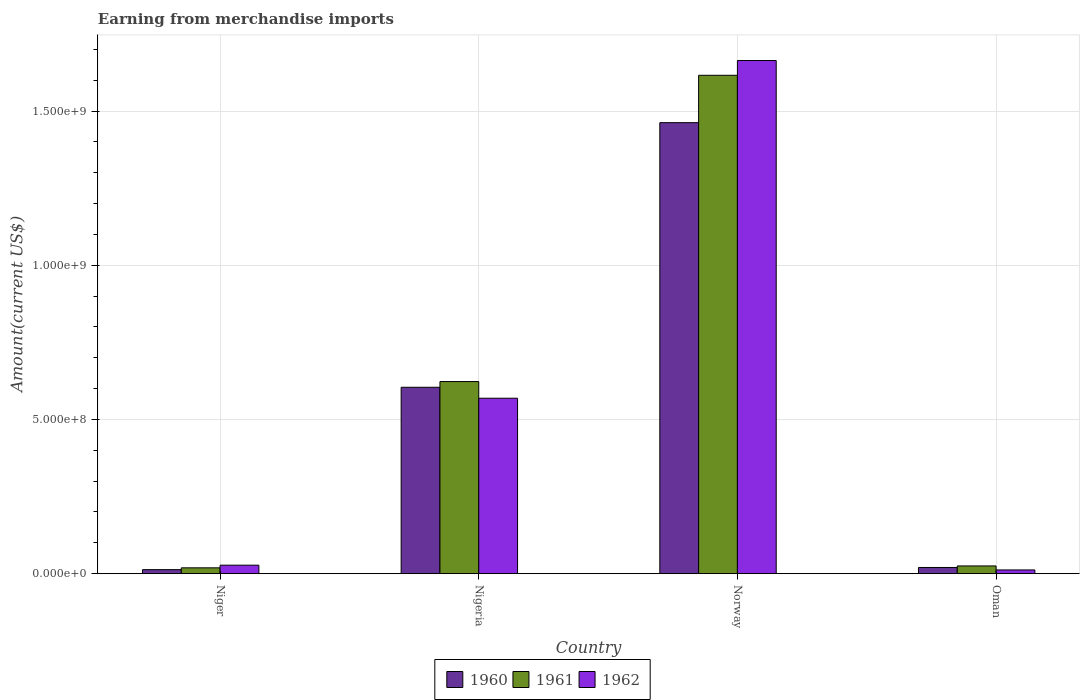Are the number of bars per tick equal to the number of legend labels?
Offer a very short reply. Yes. Are the number of bars on each tick of the X-axis equal?
Make the answer very short. Yes. How many bars are there on the 2nd tick from the left?
Give a very brief answer. 3. How many bars are there on the 1st tick from the right?
Ensure brevity in your answer.  3. What is the amount earned from merchandise imports in 1960 in Niger?
Keep it short and to the point. 1.30e+07. Across all countries, what is the maximum amount earned from merchandise imports in 1961?
Ensure brevity in your answer.  1.62e+09. Across all countries, what is the minimum amount earned from merchandise imports in 1962?
Offer a very short reply. 1.20e+07. In which country was the amount earned from merchandise imports in 1962 maximum?
Your response must be concise. Norway. In which country was the amount earned from merchandise imports in 1960 minimum?
Your answer should be compact. Niger. What is the total amount earned from merchandise imports in 1962 in the graph?
Ensure brevity in your answer.  2.27e+09. What is the difference between the amount earned from merchandise imports in 1961 in Niger and that in Oman?
Offer a very short reply. -6.15e+06. What is the difference between the amount earned from merchandise imports in 1960 in Oman and the amount earned from merchandise imports in 1961 in Nigeria?
Your response must be concise. -6.03e+08. What is the average amount earned from merchandise imports in 1961 per country?
Your answer should be compact. 5.71e+08. What is the difference between the amount earned from merchandise imports of/in 1962 and amount earned from merchandise imports of/in 1960 in Oman?
Your response must be concise. -8.00e+06. In how many countries, is the amount earned from merchandise imports in 1962 greater than 800000000 US$?
Make the answer very short. 1. What is the ratio of the amount earned from merchandise imports in 1961 in Niger to that in Oman?
Your answer should be compact. 0.75. Is the amount earned from merchandise imports in 1962 in Norway less than that in Oman?
Your response must be concise. No. Is the difference between the amount earned from merchandise imports in 1962 in Niger and Norway greater than the difference between the amount earned from merchandise imports in 1960 in Niger and Norway?
Keep it short and to the point. No. What is the difference between the highest and the second highest amount earned from merchandise imports in 1961?
Give a very brief answer. 1.59e+09. What is the difference between the highest and the lowest amount earned from merchandise imports in 1962?
Give a very brief answer. 1.65e+09. In how many countries, is the amount earned from merchandise imports in 1962 greater than the average amount earned from merchandise imports in 1962 taken over all countries?
Your response must be concise. 2. What does the 3rd bar from the left in Nigeria represents?
Your response must be concise. 1962. Is it the case that in every country, the sum of the amount earned from merchandise imports in 1962 and amount earned from merchandise imports in 1961 is greater than the amount earned from merchandise imports in 1960?
Provide a short and direct response. Yes. How many bars are there?
Provide a short and direct response. 12. How many countries are there in the graph?
Provide a short and direct response. 4. Does the graph contain any zero values?
Your answer should be compact. No. Where does the legend appear in the graph?
Give a very brief answer. Bottom center. How are the legend labels stacked?
Provide a short and direct response. Horizontal. What is the title of the graph?
Your response must be concise. Earning from merchandise imports. What is the label or title of the Y-axis?
Your answer should be compact. Amount(current US$). What is the Amount(current US$) of 1960 in Niger?
Your answer should be compact. 1.30e+07. What is the Amount(current US$) in 1961 in Niger?
Give a very brief answer. 1.88e+07. What is the Amount(current US$) of 1962 in Niger?
Offer a terse response. 2.75e+07. What is the Amount(current US$) in 1960 in Nigeria?
Your response must be concise. 6.04e+08. What is the Amount(current US$) of 1961 in Nigeria?
Provide a succinct answer. 6.23e+08. What is the Amount(current US$) in 1962 in Nigeria?
Your answer should be compact. 5.69e+08. What is the Amount(current US$) of 1960 in Norway?
Provide a succinct answer. 1.46e+09. What is the Amount(current US$) of 1961 in Norway?
Provide a succinct answer. 1.62e+09. What is the Amount(current US$) in 1962 in Norway?
Make the answer very short. 1.66e+09. What is the Amount(current US$) in 1961 in Oman?
Your response must be concise. 2.50e+07. Across all countries, what is the maximum Amount(current US$) in 1960?
Offer a very short reply. 1.46e+09. Across all countries, what is the maximum Amount(current US$) of 1961?
Give a very brief answer. 1.62e+09. Across all countries, what is the maximum Amount(current US$) of 1962?
Your answer should be compact. 1.66e+09. Across all countries, what is the minimum Amount(current US$) of 1960?
Ensure brevity in your answer.  1.30e+07. Across all countries, what is the minimum Amount(current US$) of 1961?
Offer a terse response. 1.88e+07. Across all countries, what is the minimum Amount(current US$) in 1962?
Keep it short and to the point. 1.20e+07. What is the total Amount(current US$) of 1960 in the graph?
Give a very brief answer. 2.10e+09. What is the total Amount(current US$) in 1961 in the graph?
Make the answer very short. 2.28e+09. What is the total Amount(current US$) in 1962 in the graph?
Your answer should be compact. 2.27e+09. What is the difference between the Amount(current US$) of 1960 in Niger and that in Nigeria?
Your answer should be compact. -5.91e+08. What is the difference between the Amount(current US$) of 1961 in Niger and that in Nigeria?
Keep it short and to the point. -6.04e+08. What is the difference between the Amount(current US$) of 1962 in Niger and that in Nigeria?
Your answer should be very brief. -5.41e+08. What is the difference between the Amount(current US$) of 1960 in Niger and that in Norway?
Offer a very short reply. -1.45e+09. What is the difference between the Amount(current US$) of 1961 in Niger and that in Norway?
Your answer should be very brief. -1.60e+09. What is the difference between the Amount(current US$) of 1962 in Niger and that in Norway?
Provide a short and direct response. -1.64e+09. What is the difference between the Amount(current US$) of 1960 in Niger and that in Oman?
Provide a short and direct response. -7.01e+06. What is the difference between the Amount(current US$) of 1961 in Niger and that in Oman?
Provide a succinct answer. -6.15e+06. What is the difference between the Amount(current US$) of 1962 in Niger and that in Oman?
Your response must be concise. 1.55e+07. What is the difference between the Amount(current US$) of 1960 in Nigeria and that in Norway?
Make the answer very short. -8.58e+08. What is the difference between the Amount(current US$) of 1961 in Nigeria and that in Norway?
Your answer should be compact. -9.93e+08. What is the difference between the Amount(current US$) in 1962 in Nigeria and that in Norway?
Your response must be concise. -1.10e+09. What is the difference between the Amount(current US$) in 1960 in Nigeria and that in Oman?
Ensure brevity in your answer.  5.84e+08. What is the difference between the Amount(current US$) in 1961 in Nigeria and that in Oman?
Your answer should be very brief. 5.98e+08. What is the difference between the Amount(current US$) in 1962 in Nigeria and that in Oman?
Give a very brief answer. 5.57e+08. What is the difference between the Amount(current US$) in 1960 in Norway and that in Oman?
Your answer should be very brief. 1.44e+09. What is the difference between the Amount(current US$) of 1961 in Norway and that in Oman?
Give a very brief answer. 1.59e+09. What is the difference between the Amount(current US$) of 1962 in Norway and that in Oman?
Your answer should be compact. 1.65e+09. What is the difference between the Amount(current US$) of 1960 in Niger and the Amount(current US$) of 1961 in Nigeria?
Provide a short and direct response. -6.10e+08. What is the difference between the Amount(current US$) of 1960 in Niger and the Amount(current US$) of 1962 in Nigeria?
Provide a short and direct response. -5.56e+08. What is the difference between the Amount(current US$) of 1961 in Niger and the Amount(current US$) of 1962 in Nigeria?
Offer a terse response. -5.50e+08. What is the difference between the Amount(current US$) of 1960 in Niger and the Amount(current US$) of 1961 in Norway?
Offer a very short reply. -1.60e+09. What is the difference between the Amount(current US$) of 1960 in Niger and the Amount(current US$) of 1962 in Norway?
Your answer should be very brief. -1.65e+09. What is the difference between the Amount(current US$) of 1961 in Niger and the Amount(current US$) of 1962 in Norway?
Provide a short and direct response. -1.65e+09. What is the difference between the Amount(current US$) of 1960 in Niger and the Amount(current US$) of 1961 in Oman?
Provide a short and direct response. -1.20e+07. What is the difference between the Amount(current US$) in 1960 in Niger and the Amount(current US$) in 1962 in Oman?
Offer a very short reply. 9.92e+05. What is the difference between the Amount(current US$) in 1961 in Niger and the Amount(current US$) in 1962 in Oman?
Provide a short and direct response. 6.85e+06. What is the difference between the Amount(current US$) of 1960 in Nigeria and the Amount(current US$) of 1961 in Norway?
Your response must be concise. -1.01e+09. What is the difference between the Amount(current US$) of 1960 in Nigeria and the Amount(current US$) of 1962 in Norway?
Your answer should be very brief. -1.06e+09. What is the difference between the Amount(current US$) in 1961 in Nigeria and the Amount(current US$) in 1962 in Norway?
Provide a short and direct response. -1.04e+09. What is the difference between the Amount(current US$) of 1960 in Nigeria and the Amount(current US$) of 1961 in Oman?
Give a very brief answer. 5.79e+08. What is the difference between the Amount(current US$) of 1960 in Nigeria and the Amount(current US$) of 1962 in Oman?
Give a very brief answer. 5.92e+08. What is the difference between the Amount(current US$) in 1961 in Nigeria and the Amount(current US$) in 1962 in Oman?
Your answer should be compact. 6.11e+08. What is the difference between the Amount(current US$) of 1960 in Norway and the Amount(current US$) of 1961 in Oman?
Ensure brevity in your answer.  1.44e+09. What is the difference between the Amount(current US$) in 1960 in Norway and the Amount(current US$) in 1962 in Oman?
Ensure brevity in your answer.  1.45e+09. What is the difference between the Amount(current US$) in 1961 in Norway and the Amount(current US$) in 1962 in Oman?
Your answer should be very brief. 1.60e+09. What is the average Amount(current US$) in 1960 per country?
Keep it short and to the point. 5.25e+08. What is the average Amount(current US$) in 1961 per country?
Make the answer very short. 5.71e+08. What is the average Amount(current US$) of 1962 per country?
Your answer should be compact. 5.68e+08. What is the difference between the Amount(current US$) of 1960 and Amount(current US$) of 1961 in Niger?
Make the answer very short. -5.86e+06. What is the difference between the Amount(current US$) in 1960 and Amount(current US$) in 1962 in Niger?
Your answer should be compact. -1.45e+07. What is the difference between the Amount(current US$) of 1961 and Amount(current US$) of 1962 in Niger?
Offer a very short reply. -8.61e+06. What is the difference between the Amount(current US$) of 1960 and Amount(current US$) of 1961 in Nigeria?
Make the answer very short. -1.85e+07. What is the difference between the Amount(current US$) of 1960 and Amount(current US$) of 1962 in Nigeria?
Your answer should be compact. 3.56e+07. What is the difference between the Amount(current US$) of 1961 and Amount(current US$) of 1962 in Nigeria?
Provide a short and direct response. 5.40e+07. What is the difference between the Amount(current US$) in 1960 and Amount(current US$) in 1961 in Norway?
Keep it short and to the point. -1.54e+08. What is the difference between the Amount(current US$) of 1960 and Amount(current US$) of 1962 in Norway?
Your answer should be compact. -2.01e+08. What is the difference between the Amount(current US$) in 1961 and Amount(current US$) in 1962 in Norway?
Give a very brief answer. -4.79e+07. What is the difference between the Amount(current US$) in 1960 and Amount(current US$) in 1961 in Oman?
Your answer should be very brief. -5.00e+06. What is the difference between the Amount(current US$) of 1960 and Amount(current US$) of 1962 in Oman?
Your answer should be very brief. 8.00e+06. What is the difference between the Amount(current US$) in 1961 and Amount(current US$) in 1962 in Oman?
Provide a short and direct response. 1.30e+07. What is the ratio of the Amount(current US$) in 1960 in Niger to that in Nigeria?
Provide a short and direct response. 0.02. What is the ratio of the Amount(current US$) of 1961 in Niger to that in Nigeria?
Ensure brevity in your answer.  0.03. What is the ratio of the Amount(current US$) in 1962 in Niger to that in Nigeria?
Make the answer very short. 0.05. What is the ratio of the Amount(current US$) in 1960 in Niger to that in Norway?
Provide a short and direct response. 0.01. What is the ratio of the Amount(current US$) in 1961 in Niger to that in Norway?
Offer a terse response. 0.01. What is the ratio of the Amount(current US$) in 1962 in Niger to that in Norway?
Make the answer very short. 0.02. What is the ratio of the Amount(current US$) in 1960 in Niger to that in Oman?
Keep it short and to the point. 0.65. What is the ratio of the Amount(current US$) in 1961 in Niger to that in Oman?
Ensure brevity in your answer.  0.75. What is the ratio of the Amount(current US$) of 1962 in Niger to that in Oman?
Your answer should be compact. 2.29. What is the ratio of the Amount(current US$) of 1960 in Nigeria to that in Norway?
Your answer should be very brief. 0.41. What is the ratio of the Amount(current US$) of 1961 in Nigeria to that in Norway?
Provide a short and direct response. 0.39. What is the ratio of the Amount(current US$) in 1962 in Nigeria to that in Norway?
Keep it short and to the point. 0.34. What is the ratio of the Amount(current US$) in 1960 in Nigeria to that in Oman?
Give a very brief answer. 30.22. What is the ratio of the Amount(current US$) of 1961 in Nigeria to that in Oman?
Your answer should be very brief. 24.91. What is the ratio of the Amount(current US$) in 1962 in Nigeria to that in Oman?
Give a very brief answer. 47.4. What is the ratio of the Amount(current US$) in 1960 in Norway to that in Oman?
Your response must be concise. 73.12. What is the ratio of the Amount(current US$) of 1961 in Norway to that in Oman?
Ensure brevity in your answer.  64.64. What is the ratio of the Amount(current US$) in 1962 in Norway to that in Oman?
Give a very brief answer. 138.66. What is the difference between the highest and the second highest Amount(current US$) of 1960?
Provide a short and direct response. 8.58e+08. What is the difference between the highest and the second highest Amount(current US$) of 1961?
Keep it short and to the point. 9.93e+08. What is the difference between the highest and the second highest Amount(current US$) in 1962?
Ensure brevity in your answer.  1.10e+09. What is the difference between the highest and the lowest Amount(current US$) of 1960?
Provide a succinct answer. 1.45e+09. What is the difference between the highest and the lowest Amount(current US$) of 1961?
Make the answer very short. 1.60e+09. What is the difference between the highest and the lowest Amount(current US$) in 1962?
Make the answer very short. 1.65e+09. 